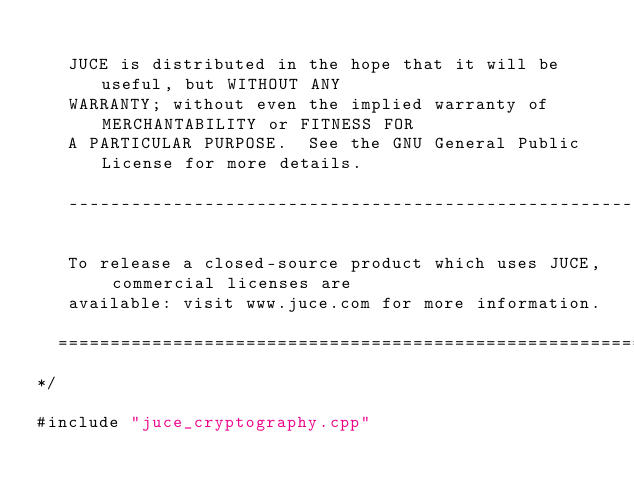Convert code to text. <code><loc_0><loc_0><loc_500><loc_500><_ObjectiveC_>
   JUCE is distributed in the hope that it will be useful, but WITHOUT ANY
   WARRANTY; without even the implied warranty of MERCHANTABILITY or FITNESS FOR
   A PARTICULAR PURPOSE.  See the GNU General Public License for more details.

   ------------------------------------------------------------------------------

   To release a closed-source product which uses JUCE, commercial licenses are
   available: visit www.juce.com for more information.

  ==============================================================================
*/

#include "juce_cryptography.cpp"
</code> 